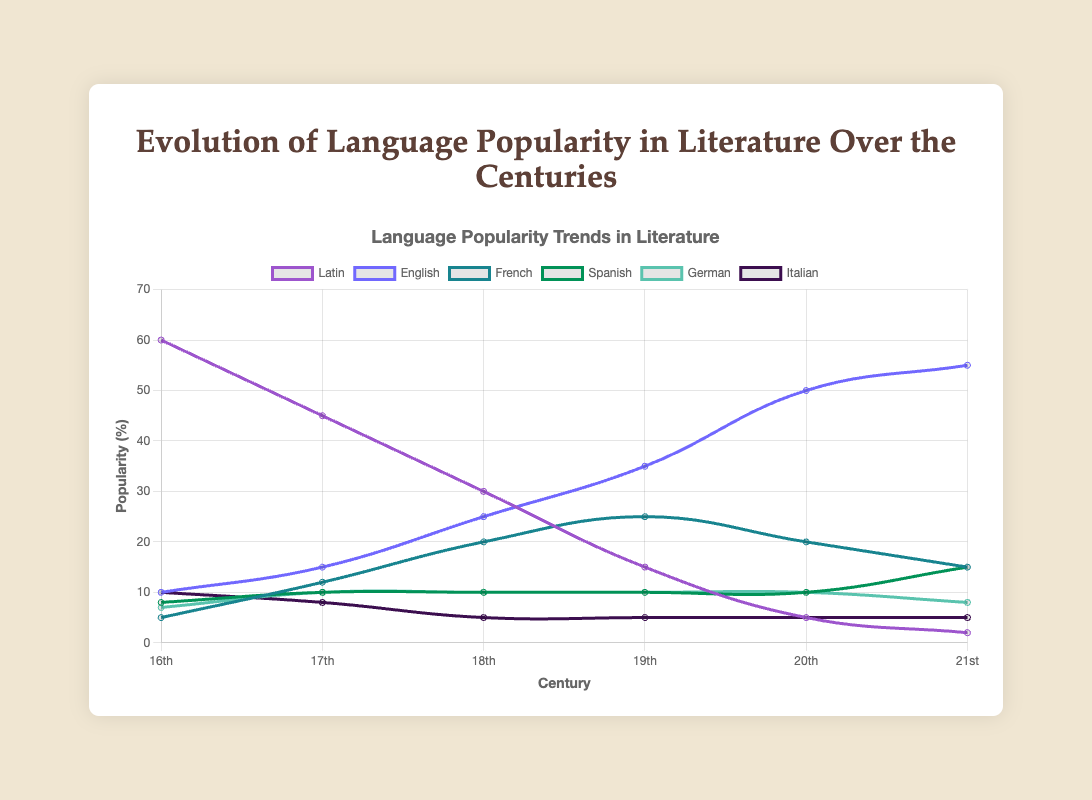What is the trend of Latin's popularity from the 16th to the 21st century? By looking at the plotted curve for Latin, you can see that it decreases steadily over each century. Starting from 60 in the 16th century, it falls to 2 by the 21st century.
Answer: Decreasing Which language shows the greatest increase in popularity between the 16th and 21st centuries? Compare the popularity percentages of each language in the 16th century and the 21st century. English increases the most, from 10% in the 16th century to 55% in the 21st century.
Answer: English What is the total popularity of French over the last four centuries? Add the popularity percentages of French for the 18th, 19th, 20th, and 21st centuries: 20 + 25 + 20 + 15.
Answer: 80 Which language was more popular in the 18th century, German or Italian? Compare the percentages for German and Italian in the 18th century. German has 10% and Italian has 5%.
Answer: German By how much does the popularity of English change between the 17th and 18th centuries? Subtract the popularity of English in the 17th century (15%) from its popularity in the 18th century (25%).
Answer: 10 Is there any century where the popularity of French is equal to another language's popularity? Yes, in the 20th century, the popularity of French (20%) is equal to Spanish (10%) and German (10%).
Answer: Yes Which two centuries have the closest popularity percentages for German? Compare the percentages of German across centuries. The 17th and 18th centuries both have 10%, and the 19th and 20th centuries also both have 10%.
Answer: 17th and 18th centuries; 19th and 20th centuries What is the average popularity of Italian over the six centuries? Sum the popularity percentages of Italian across all centuries and divide by 6: (10 + 8 + 5 + 5 + 5 + 5)/6.
Answer: 6.33 What is the difference in popularity between Spanish and Latin in the 19th century? Subtract the popularity percentage of Spanish (10%) from Latin (15%) in the 19th century.
Answer: 5 